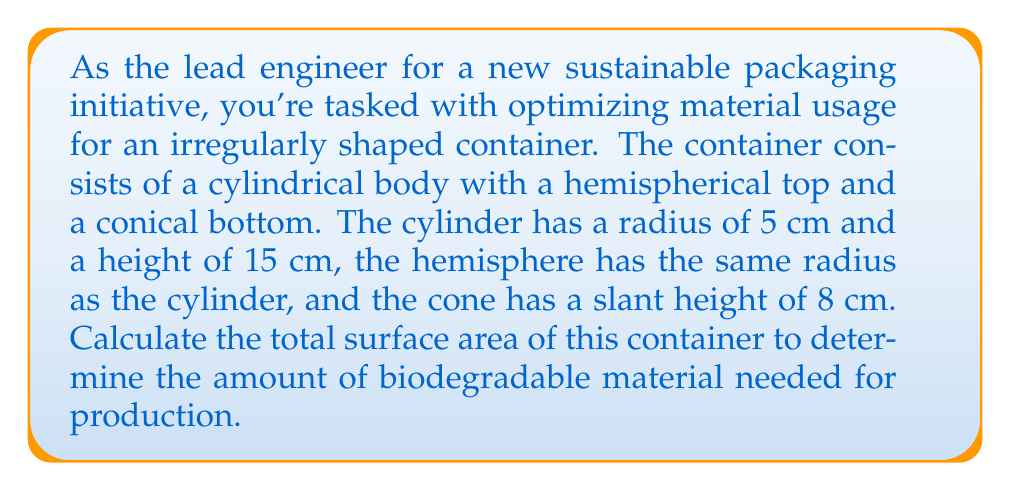Can you answer this question? Let's break this down step-by-step:

1) First, let's calculate the surface area of each component:

   a) Cylindrical body:
      - Lateral surface area: $A_{cylinder} = 2\pi rh$
      where $r$ is the radius and $h$ is the height
      $A_{cylinder} = 2\pi(5)(15) = 150\pi$ cm²

   b) Hemispherical top:
      - Surface area: $A_{hemisphere} = 2\pi r^2$
      $A_{hemisphere} = 2\pi(5^2) = 50\pi$ cm²

   c) Conical bottom:
      - Lateral surface area: $A_{cone} = \pi rs$
      where $r$ is the radius and $s$ is the slant height
      $A_{cone} = \pi(5)(8) = 40\pi$ cm²

2) Now, we need to add these areas together:
   $A_{total} = A_{cylinder} + A_{hemisphere} + A_{cone}$
   $A_{total} = 150\pi + 50\pi + 40\pi = 240\pi$ cm²

3) To get the final answer in square centimeters:
   $A_{total} = 240\pi \approx 753.98$ cm²

Note: We don't include the circular base of the cylinder or the cone in our calculations because these are where the different parts connect, not exposed surfaces.
Answer: $753.98$ cm² 